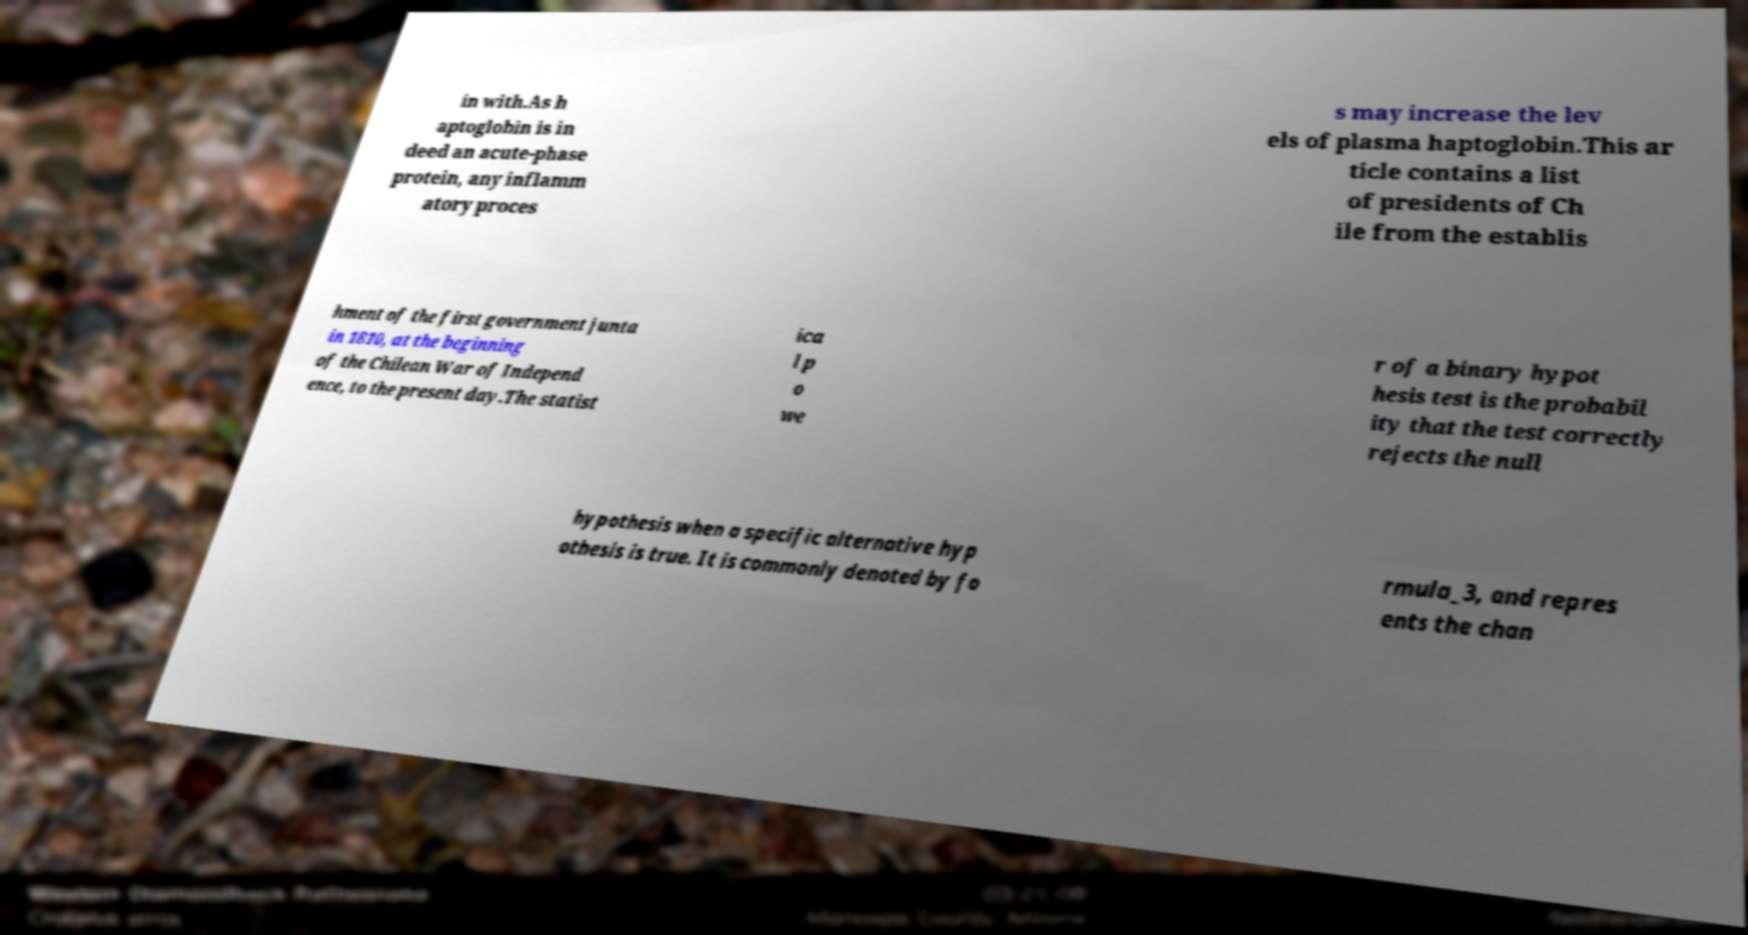For documentation purposes, I need the text within this image transcribed. Could you provide that? in with.As h aptoglobin is in deed an acute-phase protein, any inflamm atory proces s may increase the lev els of plasma haptoglobin.This ar ticle contains a list of presidents of Ch ile from the establis hment of the first government junta in 1810, at the beginning of the Chilean War of Independ ence, to the present day.The statist ica l p o we r of a binary hypot hesis test is the probabil ity that the test correctly rejects the null hypothesis when a specific alternative hyp othesis is true. It is commonly denoted by fo rmula_3, and repres ents the chan 